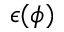Convert formula to latex. <formula><loc_0><loc_0><loc_500><loc_500>\epsilon ( \phi )</formula> 